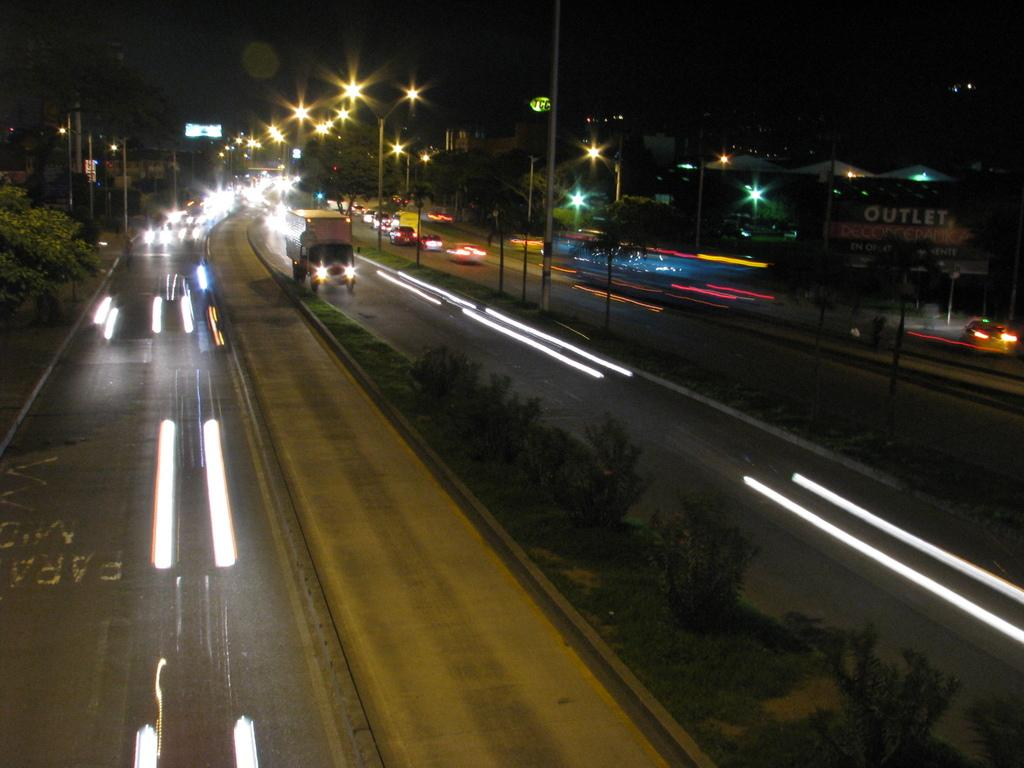What can be seen on the road in the image? There are vehicles on the road in the image. What type of lights are present on the road? Radium lights are present on the road. What structures are visible in the image? There are light poles, a hoarding, and trees present in the image. What type of vegetation is visible in the image? Plants and trees are visible in the image. What is the color of the background in the image? The background of the image is dark. What decision does the bat make while flying over the basin in the image? There is no bat or basin present in the image, so it is not possible to answer that question. 